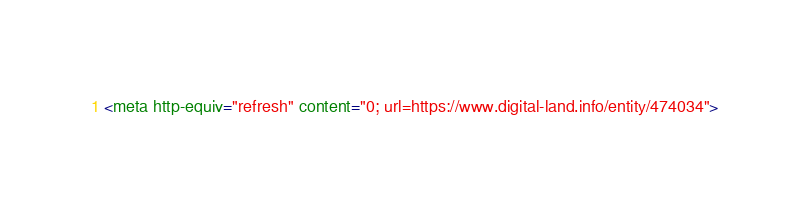<code> <loc_0><loc_0><loc_500><loc_500><_HTML_><meta http-equiv="refresh" content="0; url=https://www.digital-land.info/entity/474034"></code> 